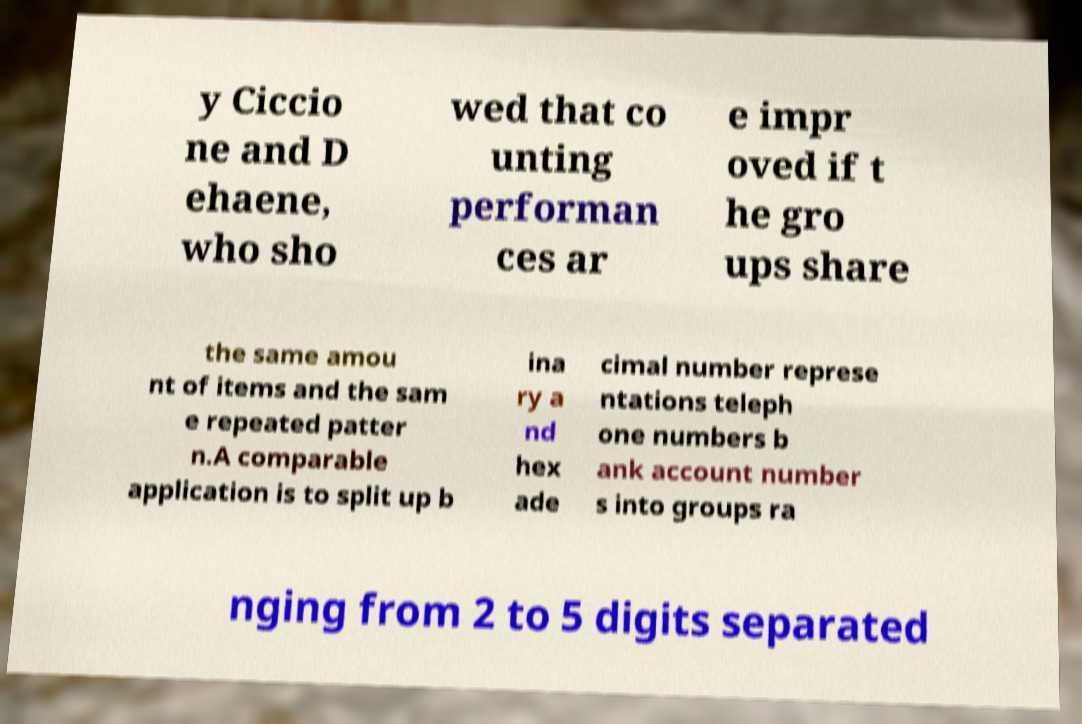Could you extract and type out the text from this image? y Ciccio ne and D ehaene, who sho wed that co unting performan ces ar e impr oved if t he gro ups share the same amou nt of items and the sam e repeated patter n.A comparable application is to split up b ina ry a nd hex ade cimal number represe ntations teleph one numbers b ank account number s into groups ra nging from 2 to 5 digits separated 